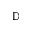<formula> <loc_0><loc_0><loc_500><loc_500>\mathbb { D }</formula> 